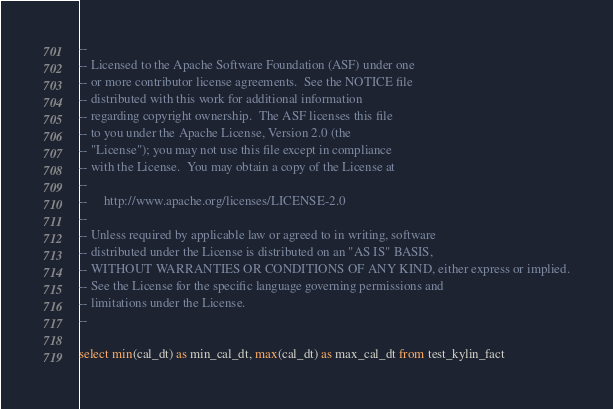Convert code to text. <code><loc_0><loc_0><loc_500><loc_500><_SQL_>--
-- Licensed to the Apache Software Foundation (ASF) under one
-- or more contributor license agreements.  See the NOTICE file
-- distributed with this work for additional information
-- regarding copyright ownership.  The ASF licenses this file
-- to you under the Apache License, Version 2.0 (the
-- "License"); you may not use this file except in compliance
-- with the License.  You may obtain a copy of the License at
--
--     http://www.apache.org/licenses/LICENSE-2.0
--
-- Unless required by applicable law or agreed to in writing, software
-- distributed under the License is distributed on an "AS IS" BASIS,
-- WITHOUT WARRANTIES OR CONDITIONS OF ANY KIND, either express or implied.
-- See the License for the specific language governing permissions and
-- limitations under the License.
--

select min(cal_dt) as min_cal_dt, max(cal_dt) as max_cal_dt from test_kylin_fact
</code> 